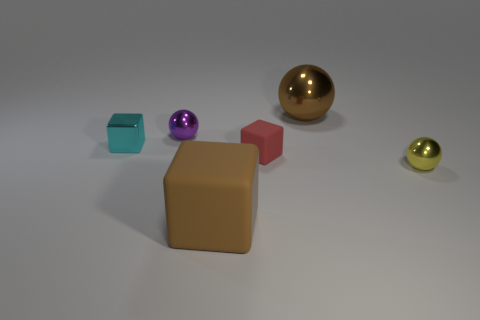What is the color of the rubber block that is the same size as the cyan metallic cube?
Make the answer very short. Red. What number of things are either brown objects that are in front of the small purple ball or shiny things right of the tiny metallic block?
Your answer should be very brief. 4. Are there the same number of large brown blocks that are behind the brown metal ball and gray spheres?
Give a very brief answer. Yes. There is a brown object behind the brown matte block; is it the same size as the matte thing in front of the red matte thing?
Give a very brief answer. Yes. How many other objects are there of the same size as the brown metal thing?
Provide a succinct answer. 1. There is a tiny cube that is on the right side of the cube on the left side of the brown matte thing; are there any metal spheres that are in front of it?
Keep it short and to the point. Yes. Is there any other thing that is the same color as the tiny rubber thing?
Your response must be concise. No. There is a sphere to the left of the brown metallic object; what size is it?
Offer a terse response. Small. What size is the object left of the tiny object that is behind the small block that is left of the purple shiny sphere?
Provide a short and direct response. Small. What color is the metallic sphere left of the large object that is to the right of the big matte cube?
Offer a terse response. Purple. 